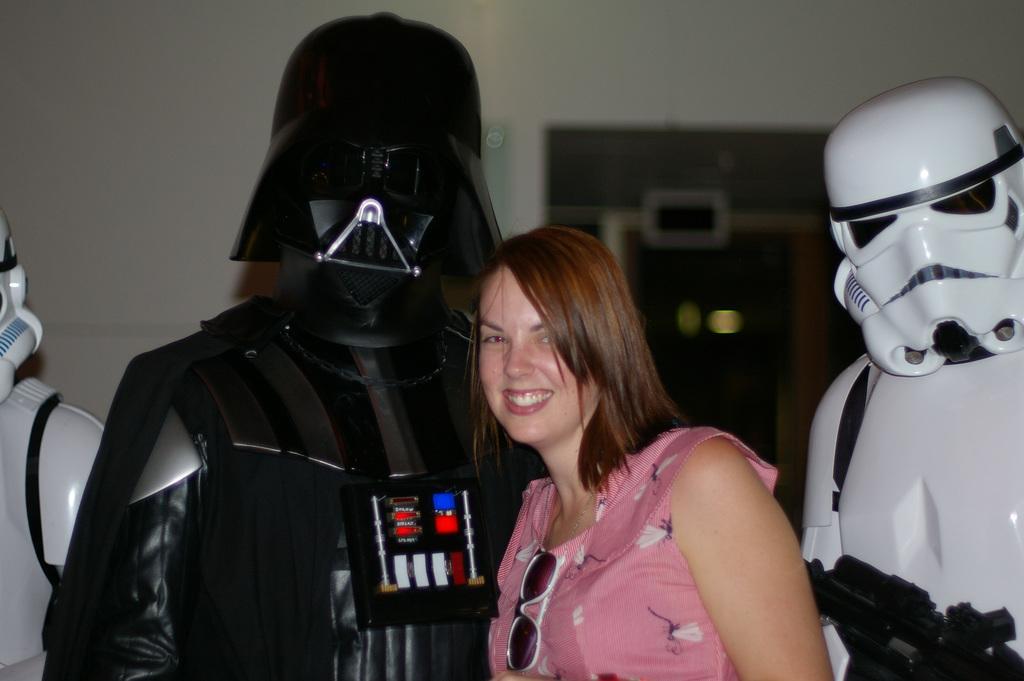Please provide a concise description of this image. In this picture there is a women wearing a pink color dress standing with black color robots, smiling and giving a pose. On the right side there is a another robot. Behind there is a white color wall. 